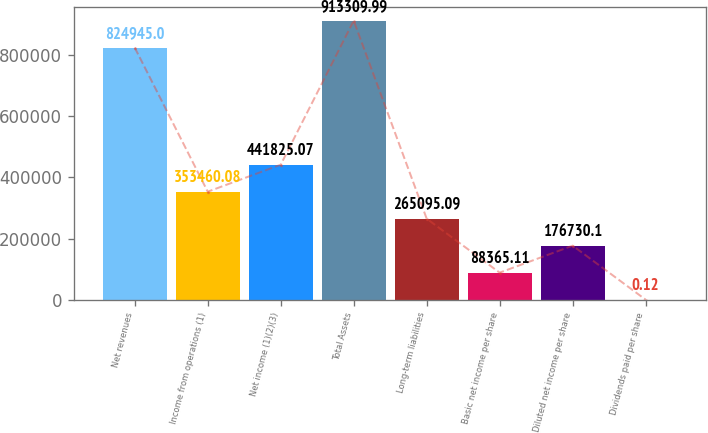Convert chart. <chart><loc_0><loc_0><loc_500><loc_500><bar_chart><fcel>Net revenues<fcel>Income from operations (1)<fcel>Net income (1)(2)(3)<fcel>Total Assets<fcel>Long-term liabilities<fcel>Basic net income per share<fcel>Diluted net income per share<fcel>Dividends paid per share<nl><fcel>824945<fcel>353460<fcel>441825<fcel>913310<fcel>265095<fcel>88365.1<fcel>176730<fcel>0.12<nl></chart> 